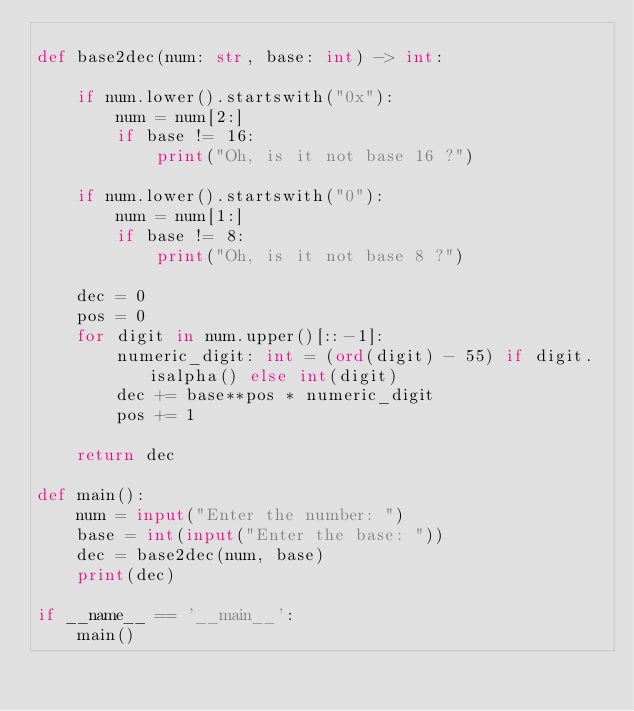<code> <loc_0><loc_0><loc_500><loc_500><_Python_>
def base2dec(num: str, base: int) -> int:

    if num.lower().startswith("0x"):
        num = num[2:]
        if base != 16:
            print("Oh, is it not base 16 ?")

    if num.lower().startswith("0"):
        num = num[1:]
        if base != 8:
            print("Oh, is it not base 8 ?")

    dec = 0
    pos = 0
    for digit in num.upper()[::-1]:
        numeric_digit: int = (ord(digit) - 55) if digit.isalpha() else int(digit)
        dec += base**pos * numeric_digit
        pos += 1

    return dec

def main():
    num = input("Enter the number: ")
    base = int(input("Enter the base: "))
    dec = base2dec(num, base)
    print(dec)

if __name__ == '__main__':
    main()

</code> 